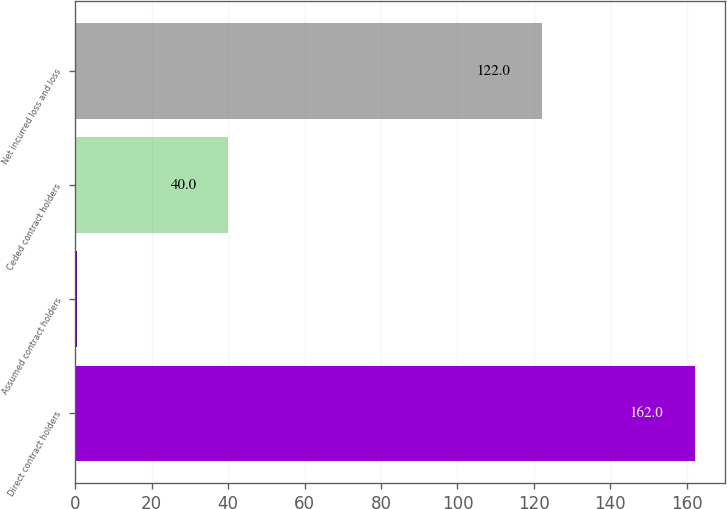Convert chart to OTSL. <chart><loc_0><loc_0><loc_500><loc_500><bar_chart><fcel>Direct contract holders<fcel>Assumed contract holders<fcel>Ceded contract holders<fcel>Net incurred loss and loss<nl><fcel>162<fcel>0.4<fcel>40<fcel>122<nl></chart> 